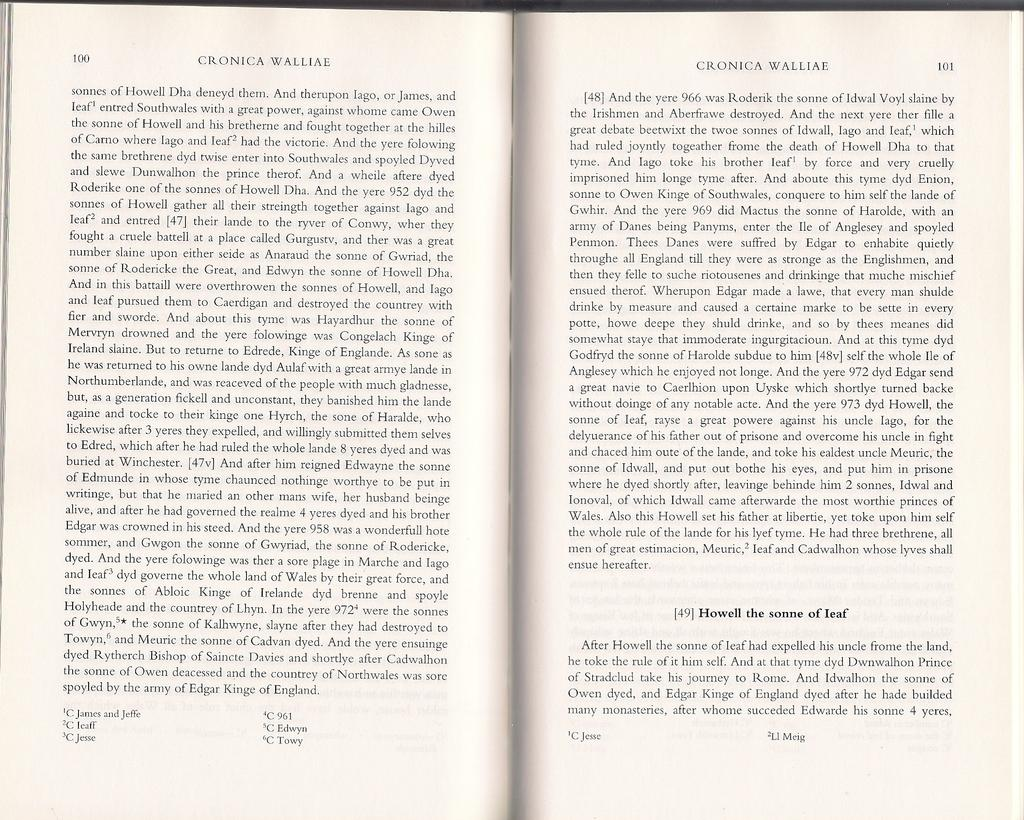<image>
Render a clear and concise summary of the photo. Two pages of a book that are numbered 100 and 101. 